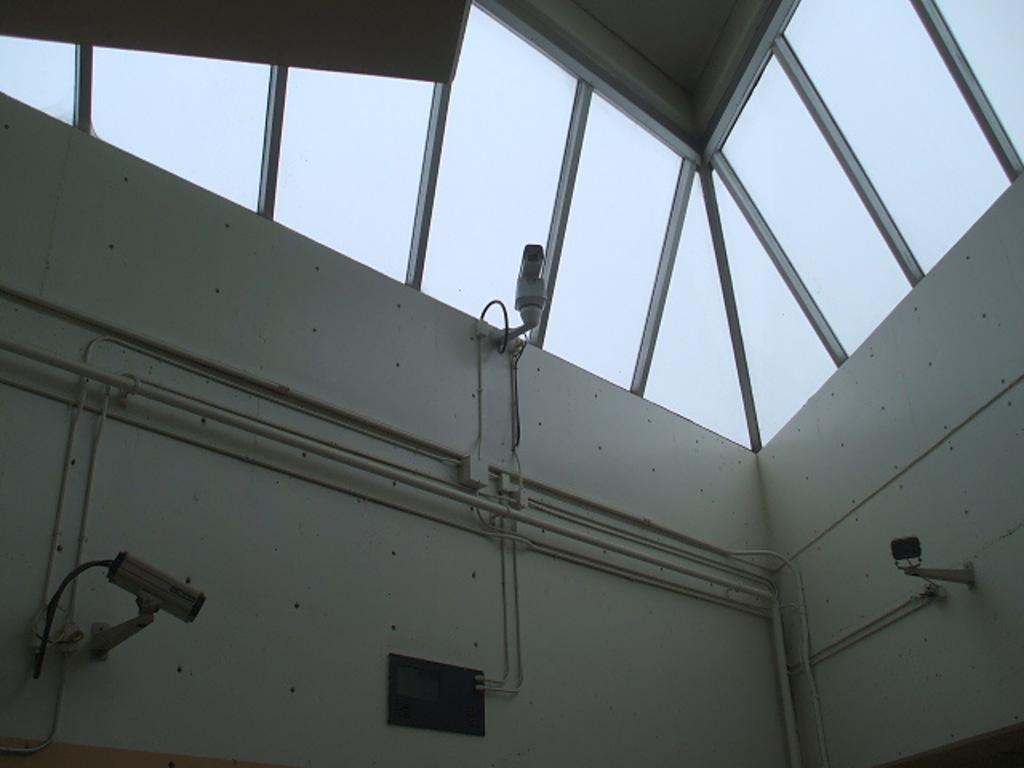What color are the walls in the image? The walls in the image are white. What type of windows can be seen in the image? There are glass windows in the image. Are there any security features visible in the image? Yes, CCTV cameras are present in the image. How many girls are playing with the root in the image? There are no girls or roots present in the image. 